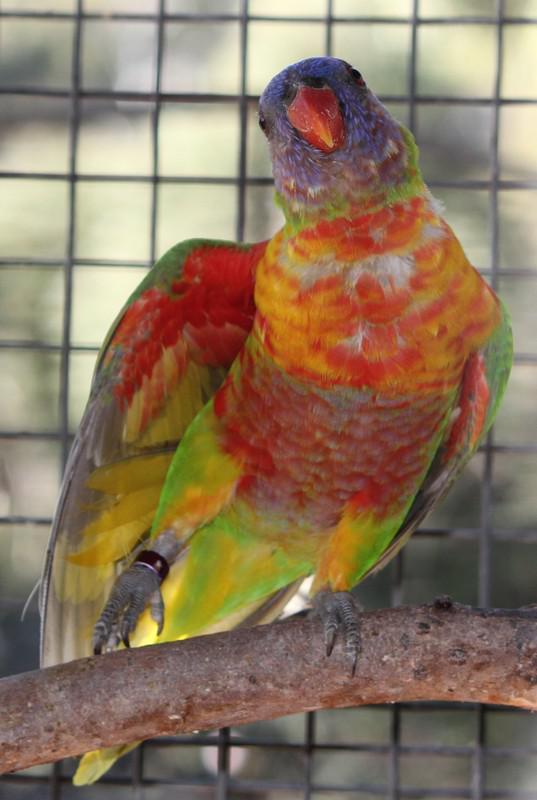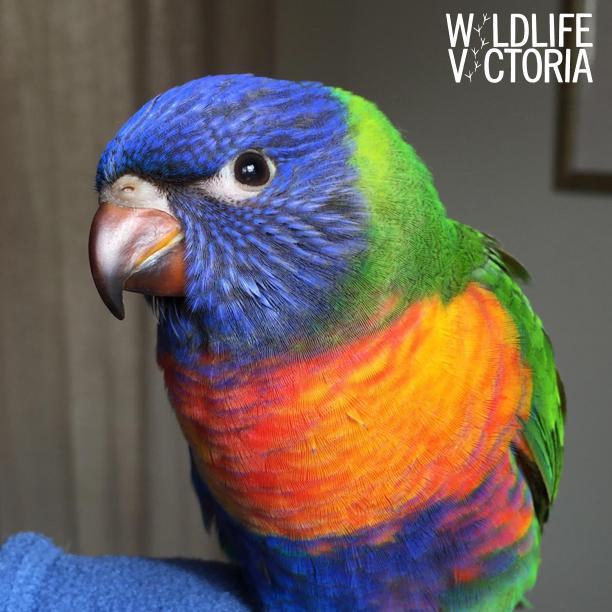The first image is the image on the left, the second image is the image on the right. Assess this claim about the two images: "An image shows a parrot with spread wings on top of a parrot that is on the ground.". Correct or not? Answer yes or no. No. The first image is the image on the left, the second image is the image on the right. For the images shown, is this caption "There are three birds with blue head." true? Answer yes or no. No. 